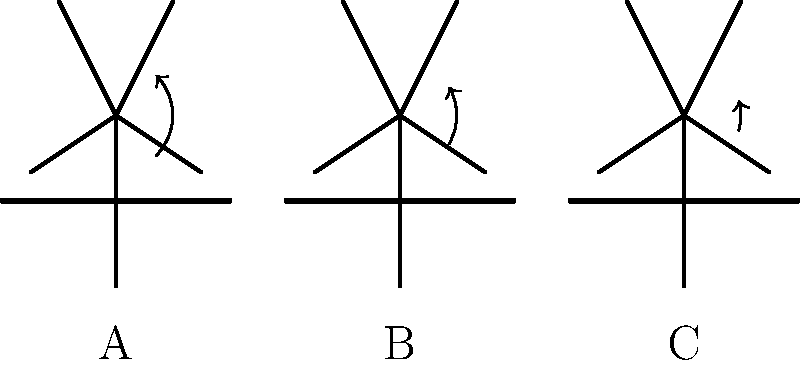Based on the stick figure diagrams shown above, which violin hold position (A, B, or C) is likely to minimize strain on the player's neck and shoulders during extended practice sessions? Explain your reasoning considering the biomechanical principles involved. To determine which violin hold position is likely to minimize strain on the player's neck and shoulders, we need to consider several biomechanical principles:

1. Neutral joint positions: Joints experience the least stress when they are in a neutral position.

2. Moment arms: The further a load is from the axis of rotation, the greater the moment arm and the more force required to support it.

3. Muscle efficiency: Muscles work most efficiently in their mid-range of motion.

4. Postural alignment: Proper alignment of the head, neck, and spine reduces overall muscular strain.

Analyzing each position:

A: The violin is held low, requiring significant neck rotation and shoulder elevation. This creates:
   - Large moment arms for both the head and the violin
   - Non-neutral joint positions in the neck and shoulders
   - Increased muscle activity to maintain the position

B: The violin is held at a moderate height with less extreme angles:
   - Reduced moment arms compared to position A
   - More neutral joint positions
   - Moderate muscle activity required

C: The violin is held high, close to the neck:
   - Smallest moment arms for the violin weight
   - Most neutral joint positions for the neck and shoulders
   - Least muscle activity required to maintain the position
   - Best postural alignment of the head, neck, and spine

Position C allows for the most neutral alignment of the head, neck, and shoulders, reducing the overall muscular effort required to support both the head and the violin. This position minimizes the moment arms, keeping the load closer to the body's center of mass, which reduces the strain on the muscles of the neck and shoulders.
Answer: Position C 